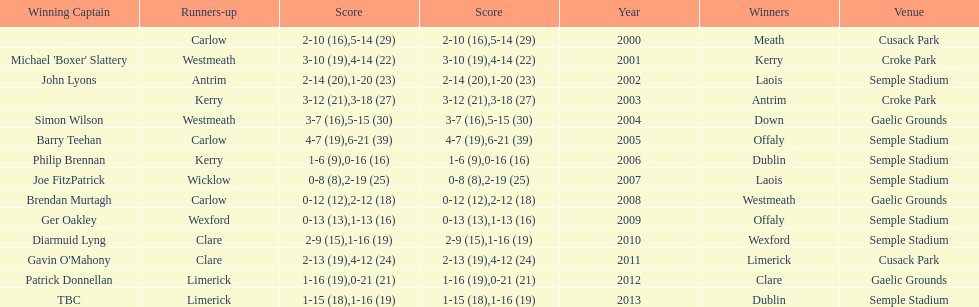Who was the winner after 2007? Laois. 